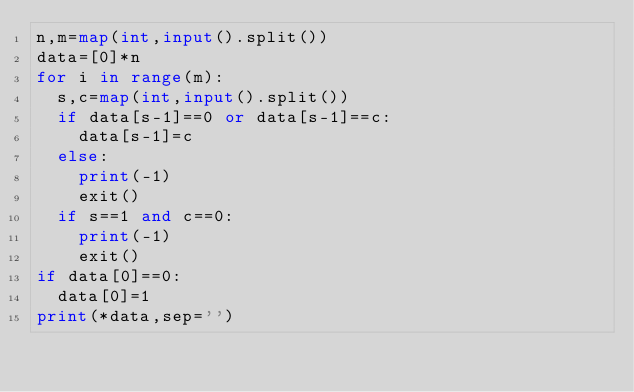Convert code to text. <code><loc_0><loc_0><loc_500><loc_500><_Python_>n,m=map(int,input().split())
data=[0]*n
for i in range(m):
  s,c=map(int,input().split())
  if data[s-1]==0 or data[s-1]==c:
    data[s-1]=c
  else:
    print(-1)
    exit()
  if s==1 and c==0:
    print(-1)
    exit()
if data[0]==0:
  data[0]=1
print(*data,sep='')</code> 